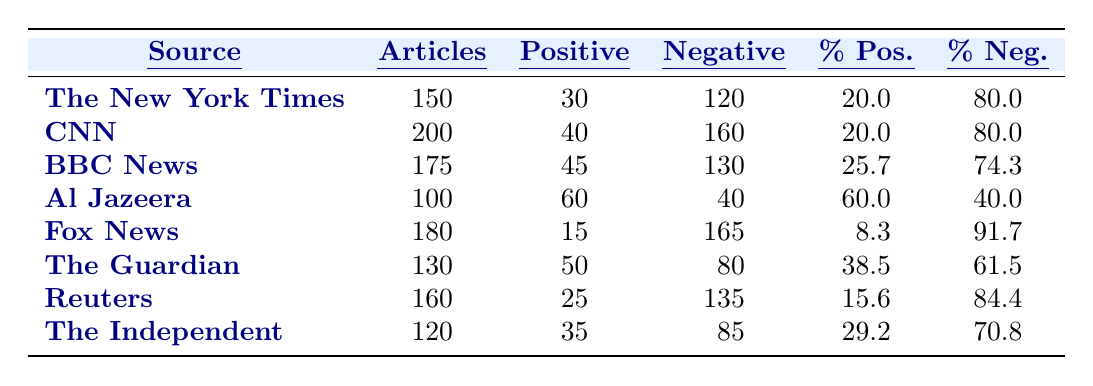What is the article count from The New York Times? The table indicates that the article count for The New York Times is listed directly in the second column next to its name, which shows 150.
Answer: 150 Which source has the highest percentage of positive stereotypes? By comparing the percentages of positive stereotypes in the table, Al Jazeera has the highest percentage at 60.0%.
Answer: Al Jazeera How many negative stereotypes does CNN mention? The number of negative stereotypes for CNN is located in the negative column next to CNN's name, which shows 160.
Answer: 160 What is the average percentage of positive stereotypes across all sources? To calculate the average percentage of positive stereotypes, we sum the percentages (20.0 + 20.0 + 25.7 + 60.0 + 8.3 + 38.5 + 15.6 + 29.2 = 237.3) and divide by the number of sources (8). Thus, the average is 237.3 / 8 = 29.66.
Answer: 29.66 Is it true that Fox News has a higher percentage of positive stereotypes than BBC News? Looking at the table, Fox News has a percentage of positive stereotypes of 8.3, while BBC News has 25.7. Since 8.3 is less than 25.7, the statement is false.
Answer: No Which source has the least positive stereotypes reported? By reviewing the positive stereotypes column for all sources, Fox News has the lowest count with 15 positive stereotypes.
Answer: Fox News What is the difference in the number of negative stereotypes between The Guardian and The Independent? The number of negative stereotypes for The Guardian is 80, and for The Independent, it is 85. The difference is calculated as 85 - 80 = 5.
Answer: 5 Which source has the highest article count and what is that count? The table shows that CNN has the highest article count at 200, which can be found in the article count column next to CNN's name.
Answer: CNN, 200 If you combine the positive stereotypes from Reuters and The Independent, how many total positive stereotypes do they report? The number of positive stereotypes from Reuters is 25, while from The Independent it is 35. Adding them together gives us 25 + 35 = 60.
Answer: 60 What percentage of articles from The Independent are negative stereotypes? The percentage of negative stereotypes for The Independent is 70.8, as shown in the table under the percentage negative column for that source.
Answer: 70.8 